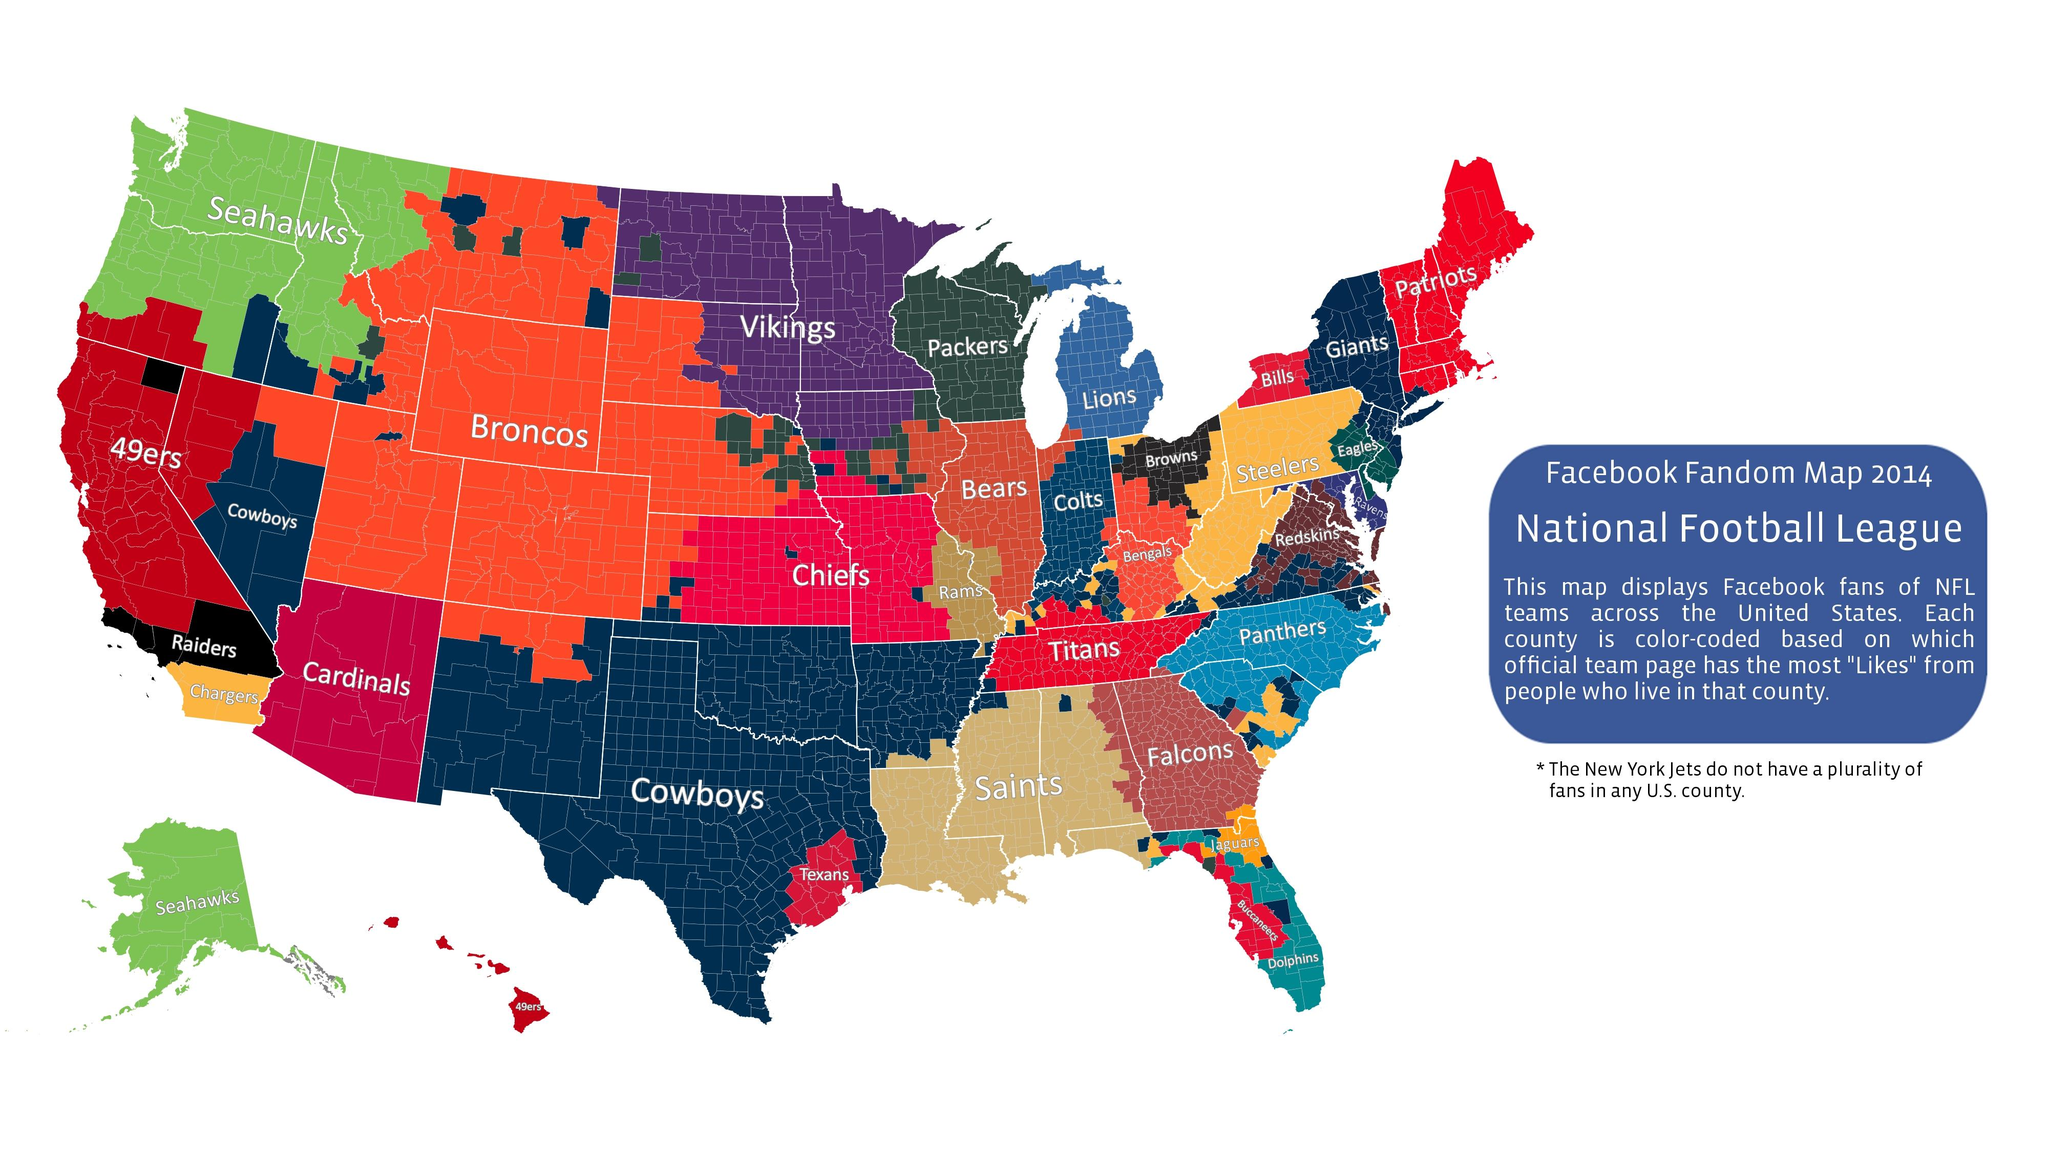Indicate a few pertinent items in this graphic. According to the data, the Patriots are the most liked team in 6 counties. The Tennessee Titans have the most number of Facebook likes among all the teams in Tennessee. The Dallas Cowboys have the most number of Facebook likes among all NFL teams. The team that receives Facebook likes from Hawaii is the San Francisco 49ers. The Seattle Seahawks football team receives Facebook likes from Alaska. 